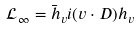<formula> <loc_0><loc_0><loc_500><loc_500>\mathcal { L } _ { \infty } = \bar { h } _ { v } i ( v \cdot D ) h _ { v }</formula> 